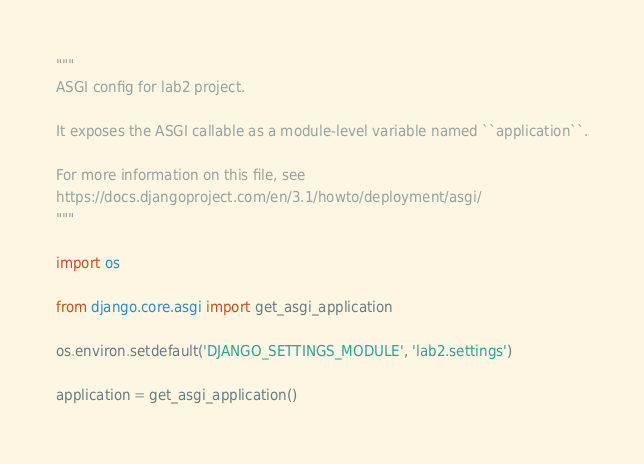<code> <loc_0><loc_0><loc_500><loc_500><_Python_>"""
ASGI config for lab2 project.

It exposes the ASGI callable as a module-level variable named ``application``.

For more information on this file, see
https://docs.djangoproject.com/en/3.1/howto/deployment/asgi/
"""

import os

from django.core.asgi import get_asgi_application

os.environ.setdefault('DJANGO_SETTINGS_MODULE', 'lab2.settings')

application = get_asgi_application()
</code> 